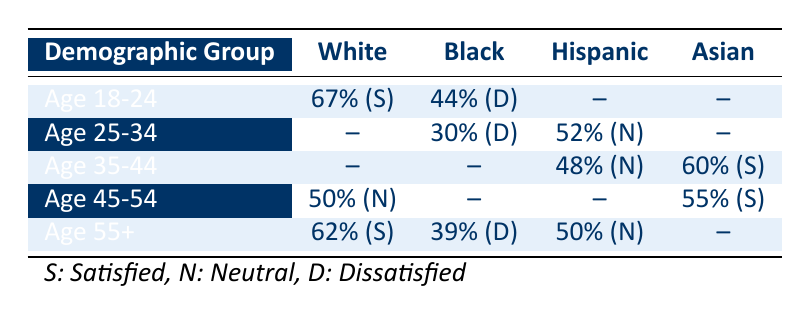What is the public opinion effectiveness for White individuals aged 18-24? According to the table, the public opinion effectiveness for White individuals in the Age 18-24 group is 67%.
Answer: 67% What is the satisfaction level of Black individuals aged 35-44 regarding the justice system effectiveness? The table shows that there is no reported effectiveness percentage for Black individuals in the Age 35-44 category, indicating it is not applicable; hence we cannot determine their satisfaction level.
Answer: Not Applicable Which demographic group shows the highest public opinion effectiveness rating? By analyzing the table, the highest rating is from White individuals aged 18-24 with 67%.
Answer: 67% How do the public opinion effectiveness ratings for Black individuals compare between ages 18-24 and 55+? The effectiveness for Black individuals aged 18-24 is 44%, while for those aged 55+, it is 39%. Comparing the two shows that the rating for the younger group is higher by 5%.
Answer: 5% higher for Age 18-24 Is there a demographic group with a neutral satisfaction level? Yes, both the Age 25-34 group of Hispanic individuals and the Age 45-54 group of White individuals exhibit neutral satisfaction, as indicated by the rating of "Neutral" in the table.
Answer: Yes What is the average public opinion effectiveness for Hispanic individuals across the specified age groups? The Hispanic individuals aged 25-34 have an effectiveness of 52%, while those aged 35-44 have an effectiveness of 48%. To calculate the average: (52 + 48) / 2 = 50.
Answer: 50% Which age group has the lowest public opinion effectiveness rating? The lowest effectiveness rating is reported for Black individuals aged 55+, which is 39%.
Answer: 39% What percentage of individuals aged 45-54 identify as satisfied and what percentage identify as dissatisfied? For individuals aged 45-54, there is one satisfied demographic (Asian at 55%) and no reported dissatisfaction, since Black or Hispanic races do not report effectiveness. Thus, the percentage satisfied is 100% for the Asian demographic while others remain unreported.
Answer: 100% satisfied (Asian) 